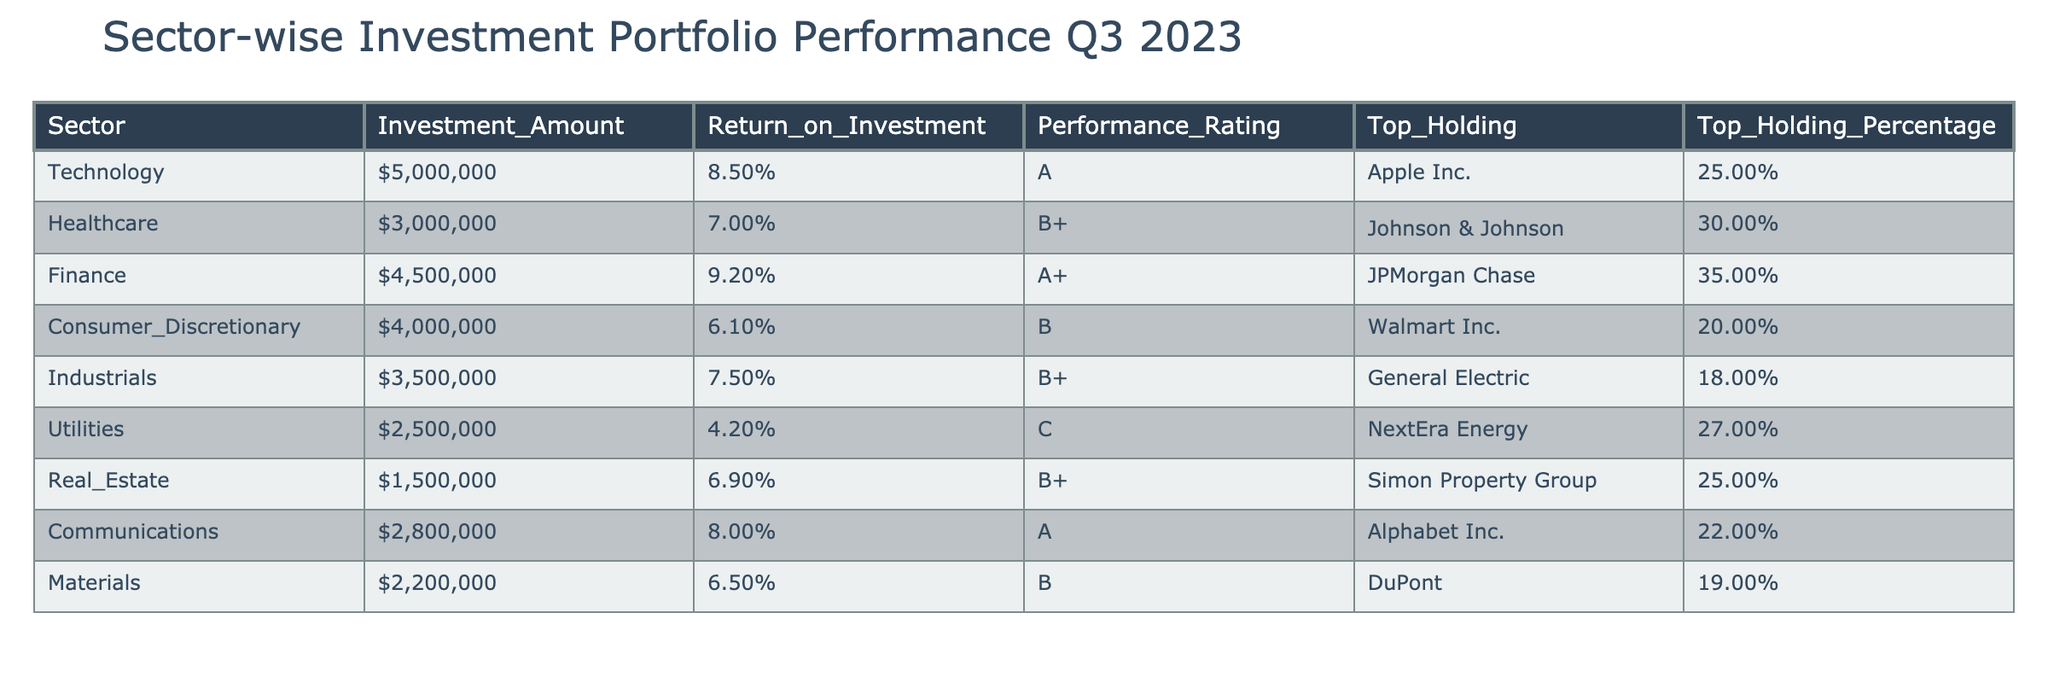What is the highest Return on Investment among the sectors? Looking at the "Return_on_Investment" column, I identify the values: 8.5%, 7.0%, 9.2%, 6.1%, 7.5%, 4.2%, 6.9%, 8.0%, 6.5%. The maximum value is 9.2% for the Finance sector.
Answer: 9.2% Which sector has the lowest Performance Rating? I observe the "Performance_Rating" column for the ratings: A, B+, A+, B, B+, C, B+, A, B. The lowest rating is C, associated with the Utilities sector.
Answer: Utilities How much was invested in the Consumer Discretionary sector? In the "Investment_Amount" column, I find the value for the Consumer Discretionary sector is listed as $4,000,000.
Answer: $4,000,000 What is the percentage of the top holding in the Healthcare sector? The "Top_Holding_Percentage" for the Healthcare sector is 30%, which is directly stated in the table.
Answer: 30% What is the average Return on Investment for all sectors? To find the average, I first convert the percentages to decimals: 0.085, 0.070, 0.092, 0.061, 0.075, 0.042, 0.069, 0.080, 0.065. Their sum is 0.085 + 0.070 + 0.092 + 0.061 + 0.075 + 0.042 + 0.069 + 0.080 + 0.065 = 0.0526. Dividing by 9 (the number of sectors), the average is approximately 0.069, which is 6.9%.
Answer: 6.9% Is the top holding in the Finance sector greater than 30%? The "Top_Holding_Percentage" for the Finance sector is 35%, which is greater than 30%.
Answer: Yes Which sector's top holding percentage is equal to or greater than 25%? I check the "Top_Holding_Percentage" and see that the Technology (25%), Healthcare (30%), Finance (35%), Real Estate (25%), and Communications (22%) sectors fit this criterion. In total, there are four sectors matching this.
Answer: 4 sectors What is the combined Investment Amount for the Technology and Finance sectors? The "Investment_Amount" for Technology is $5,000,000 and for Finance is $4,500,000. Adding these gives me $5,000,000 + $4,500,000 = $9,500,000.
Answer: $9,500,000 Which sector has the highest Investment Amount? I check the "Investment_Amount" entries: $5,000,000 (Technology), $3,000,000 (Healthcare), $4,500,000 (Finance), $4,000,000 (Consumer Discretionary), $3,500,000 (Industrials), $2,500,000 (Utilities), $1,500,000 (Real Estate), $2,800,000 (Communications), $2,200,000 (Materials). The highest amount is $5,000,000 for Technology.
Answer: Technology 